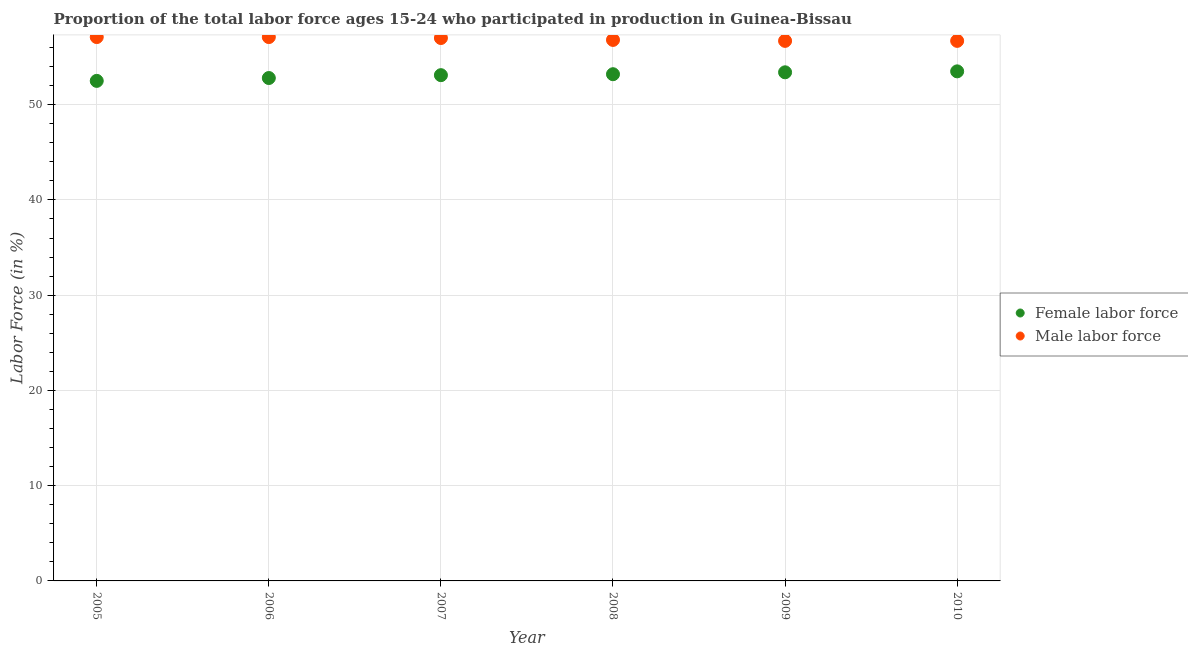What is the percentage of male labour force in 2005?
Your answer should be very brief. 57.1. Across all years, what is the maximum percentage of female labor force?
Make the answer very short. 53.5. Across all years, what is the minimum percentage of female labor force?
Provide a succinct answer. 52.5. In which year was the percentage of male labour force maximum?
Ensure brevity in your answer.  2005. In which year was the percentage of male labour force minimum?
Offer a terse response. 2009. What is the total percentage of male labour force in the graph?
Offer a terse response. 341.4. What is the difference between the percentage of female labor force in 2009 and that in 2010?
Offer a very short reply. -0.1. What is the difference between the percentage of male labour force in 2007 and the percentage of female labor force in 2010?
Offer a very short reply. 3.5. What is the average percentage of female labor force per year?
Give a very brief answer. 53.08. In the year 2009, what is the difference between the percentage of female labor force and percentage of male labour force?
Provide a succinct answer. -3.3. What is the ratio of the percentage of female labor force in 2005 to that in 2010?
Give a very brief answer. 0.98. Is the difference between the percentage of male labour force in 2006 and 2008 greater than the difference between the percentage of female labor force in 2006 and 2008?
Provide a short and direct response. Yes. What is the difference between the highest and the second highest percentage of female labor force?
Provide a succinct answer. 0.1. What is the difference between the highest and the lowest percentage of male labour force?
Your response must be concise. 0.4. Does the percentage of female labor force monotonically increase over the years?
Give a very brief answer. Yes. Is the percentage of male labour force strictly greater than the percentage of female labor force over the years?
Your answer should be very brief. Yes. What is the difference between two consecutive major ticks on the Y-axis?
Give a very brief answer. 10. Are the values on the major ticks of Y-axis written in scientific E-notation?
Ensure brevity in your answer.  No. Does the graph contain grids?
Offer a very short reply. Yes. Where does the legend appear in the graph?
Ensure brevity in your answer.  Center right. How many legend labels are there?
Your response must be concise. 2. How are the legend labels stacked?
Provide a succinct answer. Vertical. What is the title of the graph?
Give a very brief answer. Proportion of the total labor force ages 15-24 who participated in production in Guinea-Bissau. Does "Pregnant women" appear as one of the legend labels in the graph?
Offer a terse response. No. What is the Labor Force (in %) of Female labor force in 2005?
Keep it short and to the point. 52.5. What is the Labor Force (in %) in Male labor force in 2005?
Make the answer very short. 57.1. What is the Labor Force (in %) in Female labor force in 2006?
Offer a very short reply. 52.8. What is the Labor Force (in %) in Male labor force in 2006?
Offer a terse response. 57.1. What is the Labor Force (in %) in Female labor force in 2007?
Your answer should be compact. 53.1. What is the Labor Force (in %) in Female labor force in 2008?
Provide a succinct answer. 53.2. What is the Labor Force (in %) of Male labor force in 2008?
Keep it short and to the point. 56.8. What is the Labor Force (in %) in Female labor force in 2009?
Your response must be concise. 53.4. What is the Labor Force (in %) of Male labor force in 2009?
Your response must be concise. 56.7. What is the Labor Force (in %) in Female labor force in 2010?
Provide a succinct answer. 53.5. What is the Labor Force (in %) of Male labor force in 2010?
Your response must be concise. 56.7. Across all years, what is the maximum Labor Force (in %) of Female labor force?
Offer a very short reply. 53.5. Across all years, what is the maximum Labor Force (in %) in Male labor force?
Make the answer very short. 57.1. Across all years, what is the minimum Labor Force (in %) in Female labor force?
Offer a terse response. 52.5. Across all years, what is the minimum Labor Force (in %) in Male labor force?
Make the answer very short. 56.7. What is the total Labor Force (in %) in Female labor force in the graph?
Ensure brevity in your answer.  318.5. What is the total Labor Force (in %) of Male labor force in the graph?
Your answer should be compact. 341.4. What is the difference between the Labor Force (in %) in Male labor force in 2005 and that in 2006?
Keep it short and to the point. 0. What is the difference between the Labor Force (in %) in Female labor force in 2005 and that in 2007?
Your answer should be very brief. -0.6. What is the difference between the Labor Force (in %) in Male labor force in 2005 and that in 2007?
Your answer should be very brief. 0.1. What is the difference between the Labor Force (in %) of Male labor force in 2005 and that in 2008?
Your answer should be compact. 0.3. What is the difference between the Labor Force (in %) of Female labor force in 2005 and that in 2009?
Provide a short and direct response. -0.9. What is the difference between the Labor Force (in %) in Female labor force in 2005 and that in 2010?
Make the answer very short. -1. What is the difference between the Labor Force (in %) of Female labor force in 2006 and that in 2007?
Provide a short and direct response. -0.3. What is the difference between the Labor Force (in %) of Female labor force in 2006 and that in 2010?
Ensure brevity in your answer.  -0.7. What is the difference between the Labor Force (in %) of Male labor force in 2006 and that in 2010?
Provide a short and direct response. 0.4. What is the difference between the Labor Force (in %) in Female labor force in 2007 and that in 2008?
Offer a terse response. -0.1. What is the difference between the Labor Force (in %) of Female labor force in 2007 and that in 2009?
Your response must be concise. -0.3. What is the difference between the Labor Force (in %) of Female labor force in 2008 and that in 2009?
Offer a terse response. -0.2. What is the difference between the Labor Force (in %) in Male labor force in 2008 and that in 2009?
Your response must be concise. 0.1. What is the difference between the Labor Force (in %) in Male labor force in 2008 and that in 2010?
Make the answer very short. 0.1. What is the difference between the Labor Force (in %) of Female labor force in 2009 and that in 2010?
Your answer should be very brief. -0.1. What is the difference between the Labor Force (in %) in Male labor force in 2009 and that in 2010?
Keep it short and to the point. 0. What is the difference between the Labor Force (in %) of Female labor force in 2005 and the Labor Force (in %) of Male labor force in 2006?
Your response must be concise. -4.6. What is the difference between the Labor Force (in %) of Female labor force in 2005 and the Labor Force (in %) of Male labor force in 2008?
Offer a terse response. -4.3. What is the difference between the Labor Force (in %) of Female labor force in 2006 and the Labor Force (in %) of Male labor force in 2009?
Ensure brevity in your answer.  -3.9. What is the difference between the Labor Force (in %) in Female labor force in 2006 and the Labor Force (in %) in Male labor force in 2010?
Make the answer very short. -3.9. What is the difference between the Labor Force (in %) of Female labor force in 2007 and the Labor Force (in %) of Male labor force in 2008?
Offer a very short reply. -3.7. What is the difference between the Labor Force (in %) of Female labor force in 2007 and the Labor Force (in %) of Male labor force in 2010?
Give a very brief answer. -3.6. What is the difference between the Labor Force (in %) in Female labor force in 2008 and the Labor Force (in %) in Male labor force in 2009?
Your answer should be very brief. -3.5. What is the difference between the Labor Force (in %) in Female labor force in 2008 and the Labor Force (in %) in Male labor force in 2010?
Offer a terse response. -3.5. What is the average Labor Force (in %) in Female labor force per year?
Ensure brevity in your answer.  53.08. What is the average Labor Force (in %) in Male labor force per year?
Your response must be concise. 56.9. In the year 2006, what is the difference between the Labor Force (in %) in Female labor force and Labor Force (in %) in Male labor force?
Provide a short and direct response. -4.3. In the year 2007, what is the difference between the Labor Force (in %) of Female labor force and Labor Force (in %) of Male labor force?
Make the answer very short. -3.9. In the year 2008, what is the difference between the Labor Force (in %) in Female labor force and Labor Force (in %) in Male labor force?
Provide a succinct answer. -3.6. What is the ratio of the Labor Force (in %) in Male labor force in 2005 to that in 2006?
Ensure brevity in your answer.  1. What is the ratio of the Labor Force (in %) in Female labor force in 2005 to that in 2007?
Make the answer very short. 0.99. What is the ratio of the Labor Force (in %) of Male labor force in 2005 to that in 2007?
Your answer should be very brief. 1. What is the ratio of the Labor Force (in %) in Female labor force in 2005 to that in 2008?
Make the answer very short. 0.99. What is the ratio of the Labor Force (in %) of Male labor force in 2005 to that in 2008?
Provide a succinct answer. 1.01. What is the ratio of the Labor Force (in %) in Female labor force in 2005 to that in 2009?
Your answer should be very brief. 0.98. What is the ratio of the Labor Force (in %) in Male labor force in 2005 to that in 2009?
Offer a very short reply. 1.01. What is the ratio of the Labor Force (in %) in Female labor force in 2005 to that in 2010?
Provide a short and direct response. 0.98. What is the ratio of the Labor Force (in %) in Male labor force in 2005 to that in 2010?
Offer a very short reply. 1.01. What is the ratio of the Labor Force (in %) of Female labor force in 2006 to that in 2007?
Offer a terse response. 0.99. What is the ratio of the Labor Force (in %) of Female labor force in 2006 to that in 2009?
Offer a terse response. 0.99. What is the ratio of the Labor Force (in %) of Male labor force in 2006 to that in 2009?
Give a very brief answer. 1.01. What is the ratio of the Labor Force (in %) of Female labor force in 2006 to that in 2010?
Your answer should be compact. 0.99. What is the ratio of the Labor Force (in %) in Male labor force in 2006 to that in 2010?
Provide a succinct answer. 1.01. What is the ratio of the Labor Force (in %) in Female labor force in 2007 to that in 2008?
Your answer should be compact. 1. What is the ratio of the Labor Force (in %) in Female labor force in 2007 to that in 2009?
Provide a short and direct response. 0.99. What is the ratio of the Labor Force (in %) in Male labor force in 2007 to that in 2010?
Your response must be concise. 1.01. What is the ratio of the Labor Force (in %) in Male labor force in 2008 to that in 2010?
Offer a terse response. 1. What is the ratio of the Labor Force (in %) of Male labor force in 2009 to that in 2010?
Offer a very short reply. 1. What is the difference between the highest and the second highest Labor Force (in %) of Female labor force?
Your answer should be very brief. 0.1. What is the difference between the highest and the second highest Labor Force (in %) of Male labor force?
Keep it short and to the point. 0. What is the difference between the highest and the lowest Labor Force (in %) of Male labor force?
Provide a short and direct response. 0.4. 